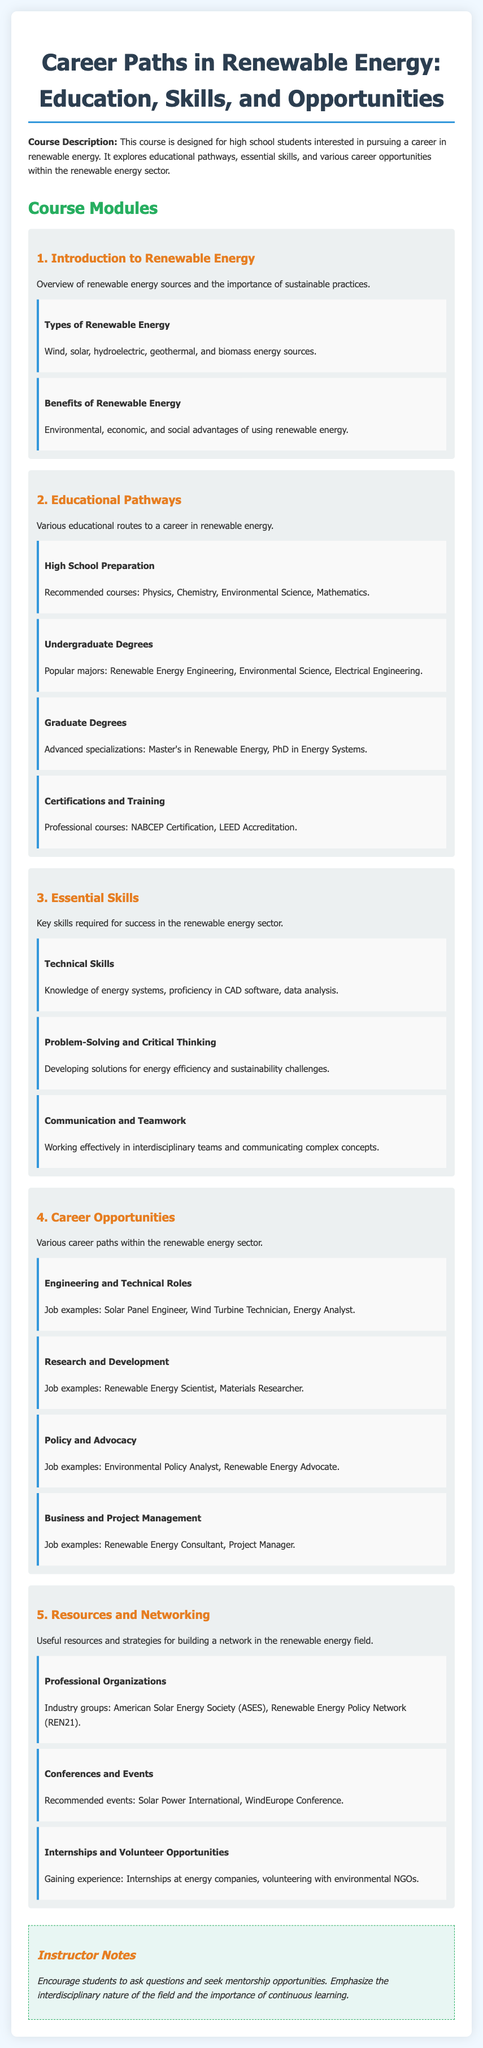What are the types of renewable energy? The document lists wind, solar, hydroelectric, geothermal, and biomass as types of renewable energy.
Answer: Wind, solar, hydroelectric, geothermal, and biomass What is a recommended high school course for preparation? The syllabus suggests physics, chemistry, environmental science, and mathematics as important courses.
Answer: Physics, Chemistry, Environmental Science, Mathematics What advanced degree is mentioned for specialization in renewable energy? The document specifies that a Master's in Renewable Energy or a PhD in Energy Systems can be pursued for advanced specialization.
Answer: Master's in Renewable Energy, PhD in Energy Systems Which professional certification is included in the document? The syllabus mentions NABCEP Certification and LEED Accreditation as professional courses for certification.
Answer: NABCEP Certification, LEED Accreditation What is an example of a job in engineering and technical roles? The document provides Solar Panel Engineer, Wind Turbine Technician, and Energy Analyst as examples of jobs in this category.
Answer: Solar Panel Engineer, Wind Turbine Technician, Energy Analyst What essential skill involves working in teams? The syllabus states that communication and teamwork are crucial for effectively working in interdisciplinary teams.
Answer: Communication and Teamwork What type of opportunities can provide experience in renewable energy? The document suggests internships at energy companies and volunteering with environmental NGOs as opportunities for gaining experience.
Answer: Internships, volunteering What organization is listed as a professional group? The syllabus includes the American Solar Energy Society as a key professional organization in renewable energy.
Answer: American Solar Energy Society What type of events can help with networking in the renewable energy field? The document suggests attending conferences such as Solar Power International and WindEurope Conference as beneficial for networking.
Answer: Conferences, events 